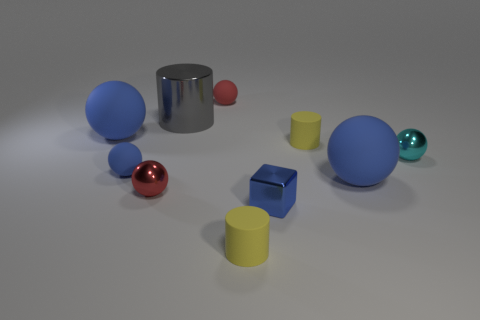What is the shape of the small rubber thing that is the same color as the small shiny cube?
Provide a short and direct response. Sphere. Does the small shiny cube have the same color as the tiny matte ball that is in front of the gray metallic cylinder?
Make the answer very short. Yes. What number of things are cylinders that are behind the cyan metal ball or small red things that are to the left of the cyan shiny object?
Your answer should be compact. 4. What is the size of the cylinder that is the same material as the cyan thing?
Offer a very short reply. Large. There is a blue rubber object to the right of the small blue sphere; does it have the same shape as the small red shiny object?
Give a very brief answer. Yes. How many brown things are small cylinders or metal balls?
Give a very brief answer. 0. What number of other objects are there of the same shape as the red matte thing?
Provide a short and direct response. 5. What shape is the metallic object that is both in front of the cyan ball and left of the red matte ball?
Your answer should be compact. Sphere. Are there any rubber cylinders in front of the tiny red metal sphere?
Your response must be concise. Yes. There is a cyan metallic object that is the same shape as the red metallic thing; what size is it?
Your response must be concise. Small. 